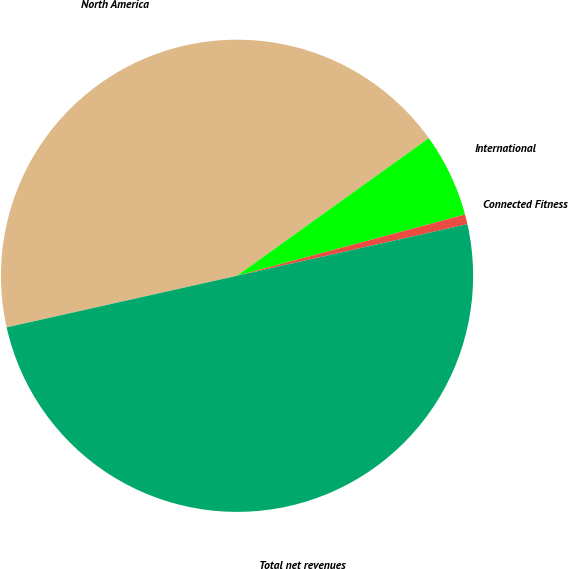Convert chart to OTSL. <chart><loc_0><loc_0><loc_500><loc_500><pie_chart><fcel>North America<fcel>International<fcel>Connected Fitness<fcel>Total net revenues<nl><fcel>43.6%<fcel>5.73%<fcel>0.67%<fcel>50.0%<nl></chart> 